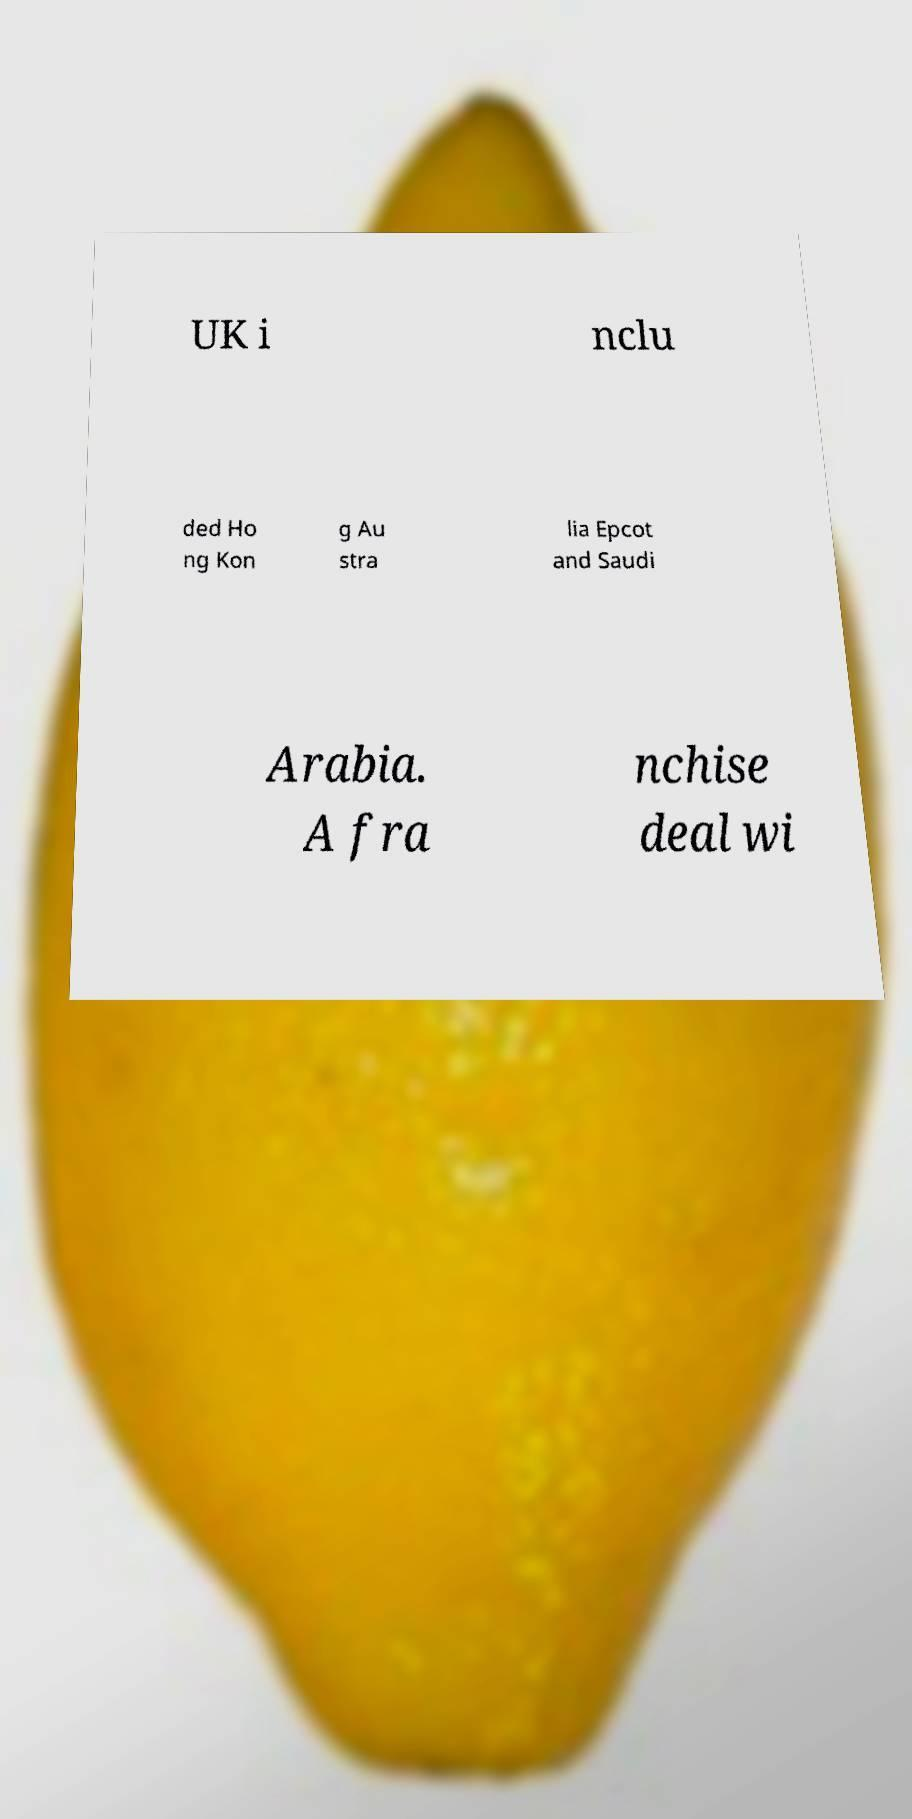Can you read and provide the text displayed in the image?This photo seems to have some interesting text. Can you extract and type it out for me? UK i nclu ded Ho ng Kon g Au stra lia Epcot and Saudi Arabia. A fra nchise deal wi 